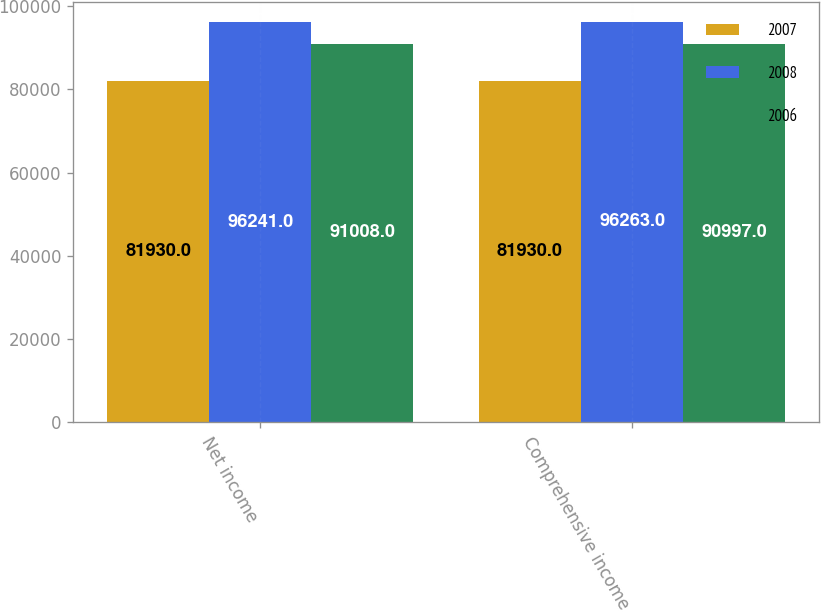Convert chart. <chart><loc_0><loc_0><loc_500><loc_500><stacked_bar_chart><ecel><fcel>Net income<fcel>Comprehensive income<nl><fcel>2007<fcel>81930<fcel>81930<nl><fcel>2008<fcel>96241<fcel>96263<nl><fcel>2006<fcel>91008<fcel>90997<nl></chart> 